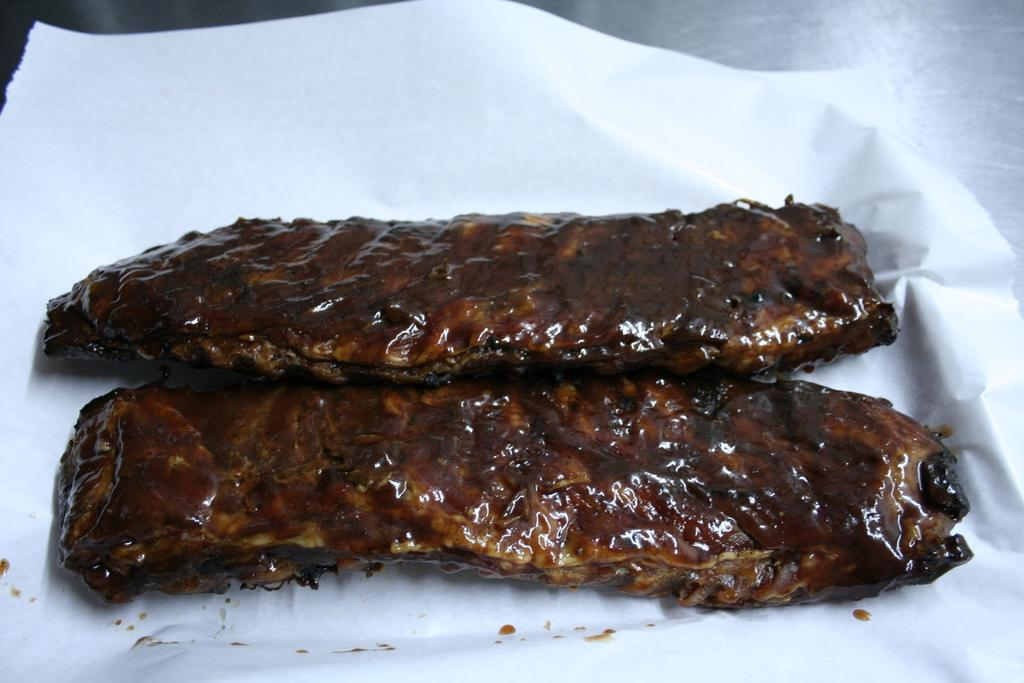What is present in the image? There is food in the image. What is the food placed on? The food is on white paper. Can you describe the surface on which the white paper is placed? The white paper is on a surface. Are there any animals from a farm present in the image? No, there are no animals from a farm present in the image. Can you see any stems on the food in the image? The provided facts do not mention any stems on the food, so it cannot be determined from the image. 